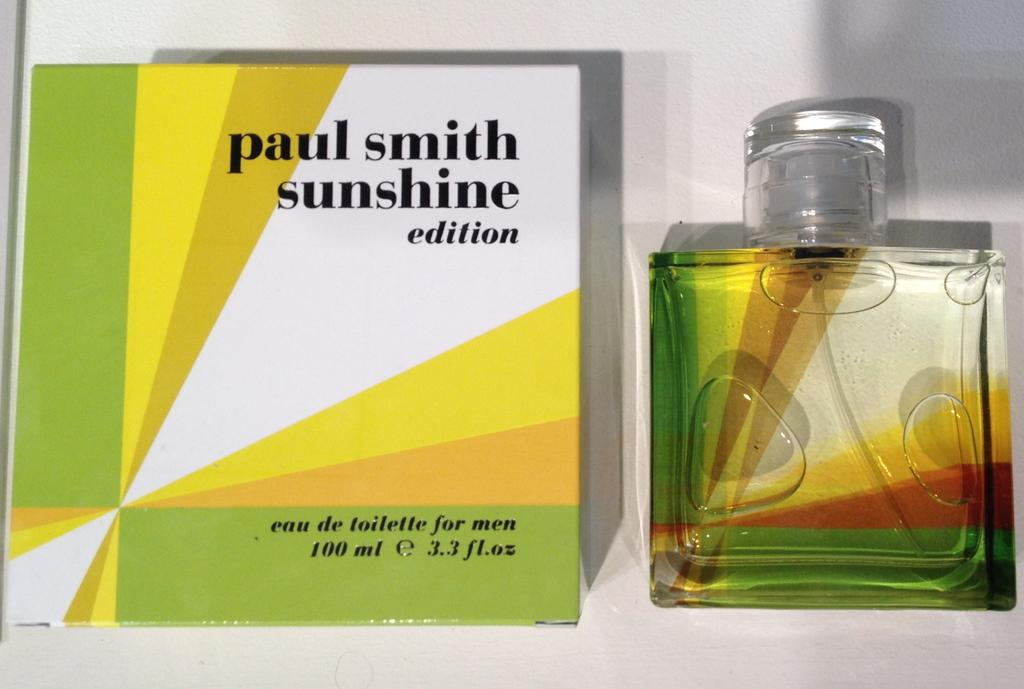<image>
Relay a brief, clear account of the picture shown. A bottle of Paul Smith Sunshine Edition is displayed next to its box. 